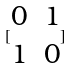Convert formula to latex. <formula><loc_0><loc_0><loc_500><loc_500>[ \begin{matrix} 0 & 1 \\ 1 & 0 \end{matrix} ]</formula> 